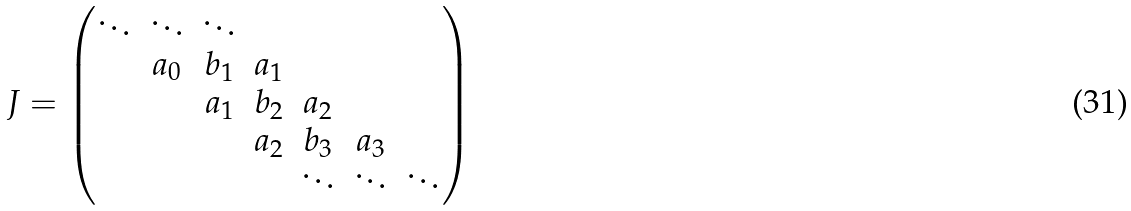<formula> <loc_0><loc_0><loc_500><loc_500>J = \begin{pmatrix} \ddots & \ddots & \ddots \\ & a _ { 0 } & b _ { 1 } & a _ { 1 } & & \\ & & a _ { 1 } & b _ { 2 } & a _ { 2 } & \\ & & & a _ { 2 } & b _ { 3 } & a _ { 3 } \\ & & & & \ddots & \ddots & \ddots \end{pmatrix}</formula> 